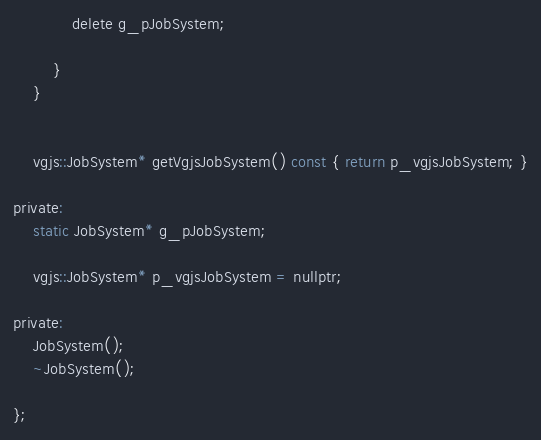Convert code to text. <code><loc_0><loc_0><loc_500><loc_500><_C_>            delete g_pJobSystem;

        }
    }


    vgjs::JobSystem* getVgjsJobSystem() const { return p_vgjsJobSystem; }

private:
    static JobSystem* g_pJobSystem;

    vgjs::JobSystem* p_vgjsJobSystem = nullptr;

private:
    JobSystem();
    ~JobSystem();

};
</code> 